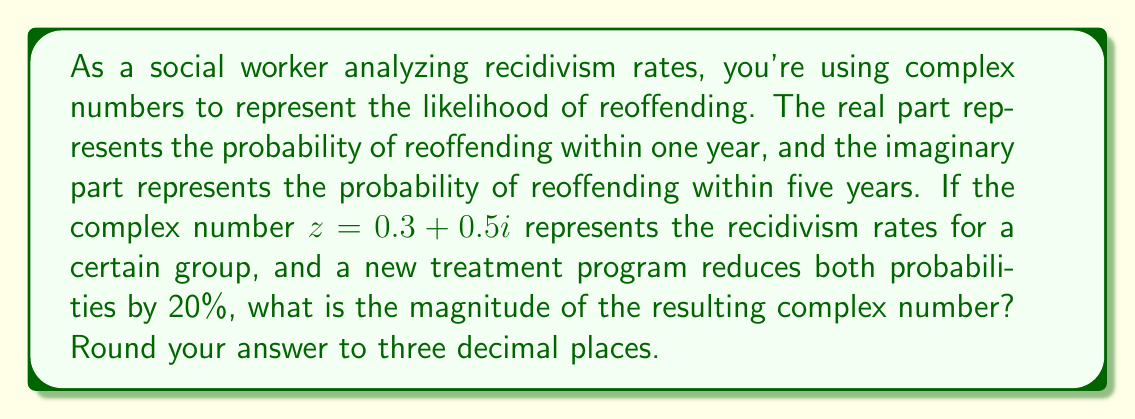Solve this math problem. To solve this problem, we'll follow these steps:

1) First, let's calculate the new complex number after the 20% reduction:
   
   Original: $z = 0.3 + 0.5i$
   
   After 20% reduction:
   Real part: $0.3 \times (1 - 0.2) = 0.3 \times 0.8 = 0.24$
   Imaginary part: $0.5 \times (1 - 0.2) = 0.5 \times 0.8 = 0.4$
   
   New complex number: $z_{new} = 0.24 + 0.4i$

2) To find the magnitude of this complex number, we use the formula:
   
   $|z| = \sqrt{a^2 + b^2}$, where $z = a + bi$

3) Substituting our values:
   
   $|z_{new}| = \sqrt{0.24^2 + 0.4^2}$

4) Calculate:
   
   $|z_{new}| = \sqrt{0.0576 + 0.16}$
   $|z_{new}| = \sqrt{0.2176}$
   $|z_{new}| \approx 0.4664$

5) Rounding to three decimal places:
   
   $|z_{new}| \approx 0.466$

This magnitude represents the overall likelihood of reoffending, considering both the one-year and five-year probabilities.
Answer: $0.466$ 